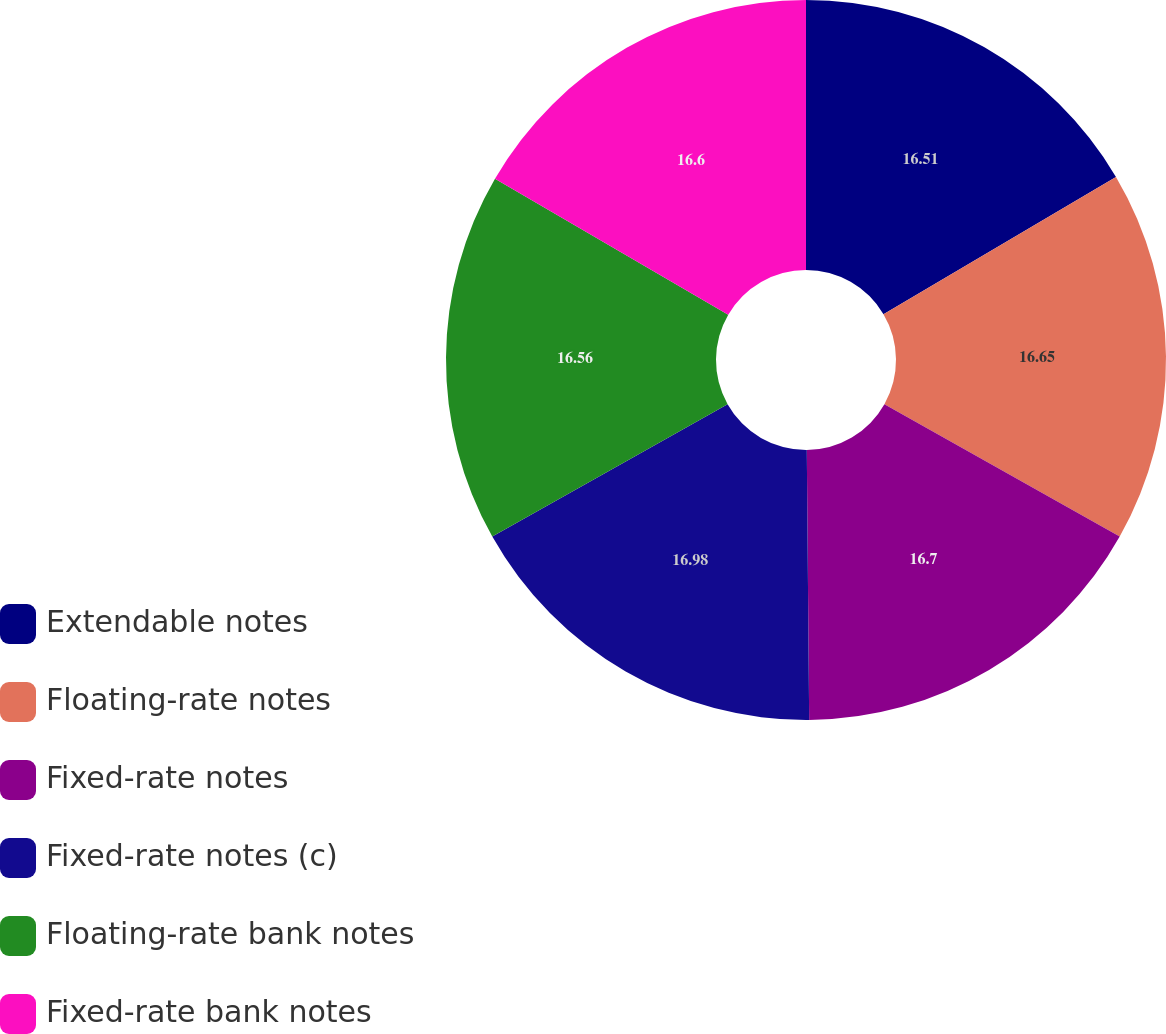Convert chart. <chart><loc_0><loc_0><loc_500><loc_500><pie_chart><fcel>Extendable notes<fcel>Floating-rate notes<fcel>Fixed-rate notes<fcel>Fixed-rate notes (c)<fcel>Floating-rate bank notes<fcel>Fixed-rate bank notes<nl><fcel>16.51%<fcel>16.65%<fcel>16.7%<fcel>16.98%<fcel>16.56%<fcel>16.6%<nl></chart> 